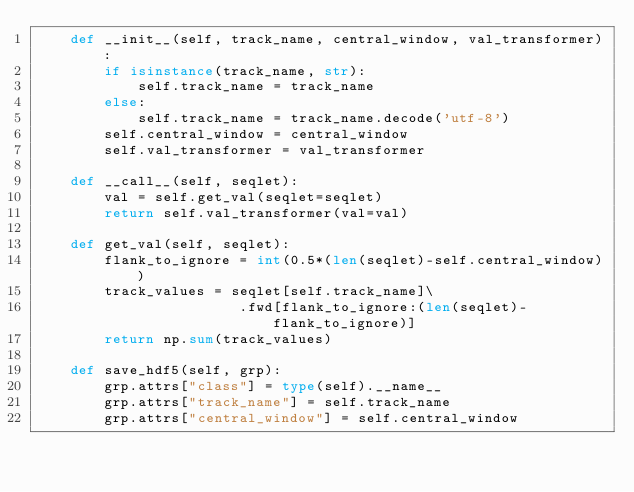Convert code to text. <code><loc_0><loc_0><loc_500><loc_500><_Python_>    def __init__(self, track_name, central_window, val_transformer):
        if isinstance(track_name, str):
            self.track_name = track_name
        else: 
            self.track_name = track_name.decode('utf-8')
        self.central_window = central_window
        self.val_transformer = val_transformer

    def __call__(self, seqlet):
        val = self.get_val(seqlet=seqlet)
        return self.val_transformer(val=val)

    def get_val(self, seqlet):
        flank_to_ignore = int(0.5*(len(seqlet)-self.central_window))
        track_values = seqlet[self.track_name]\
                        .fwd[flank_to_ignore:(len(seqlet)-flank_to_ignore)]
        return np.sum(track_values)

    def save_hdf5(self, grp):
        grp.attrs["class"] = type(self).__name__
        grp.attrs["track_name"] = self.track_name
        grp.attrs["central_window"] = self.central_window</code> 